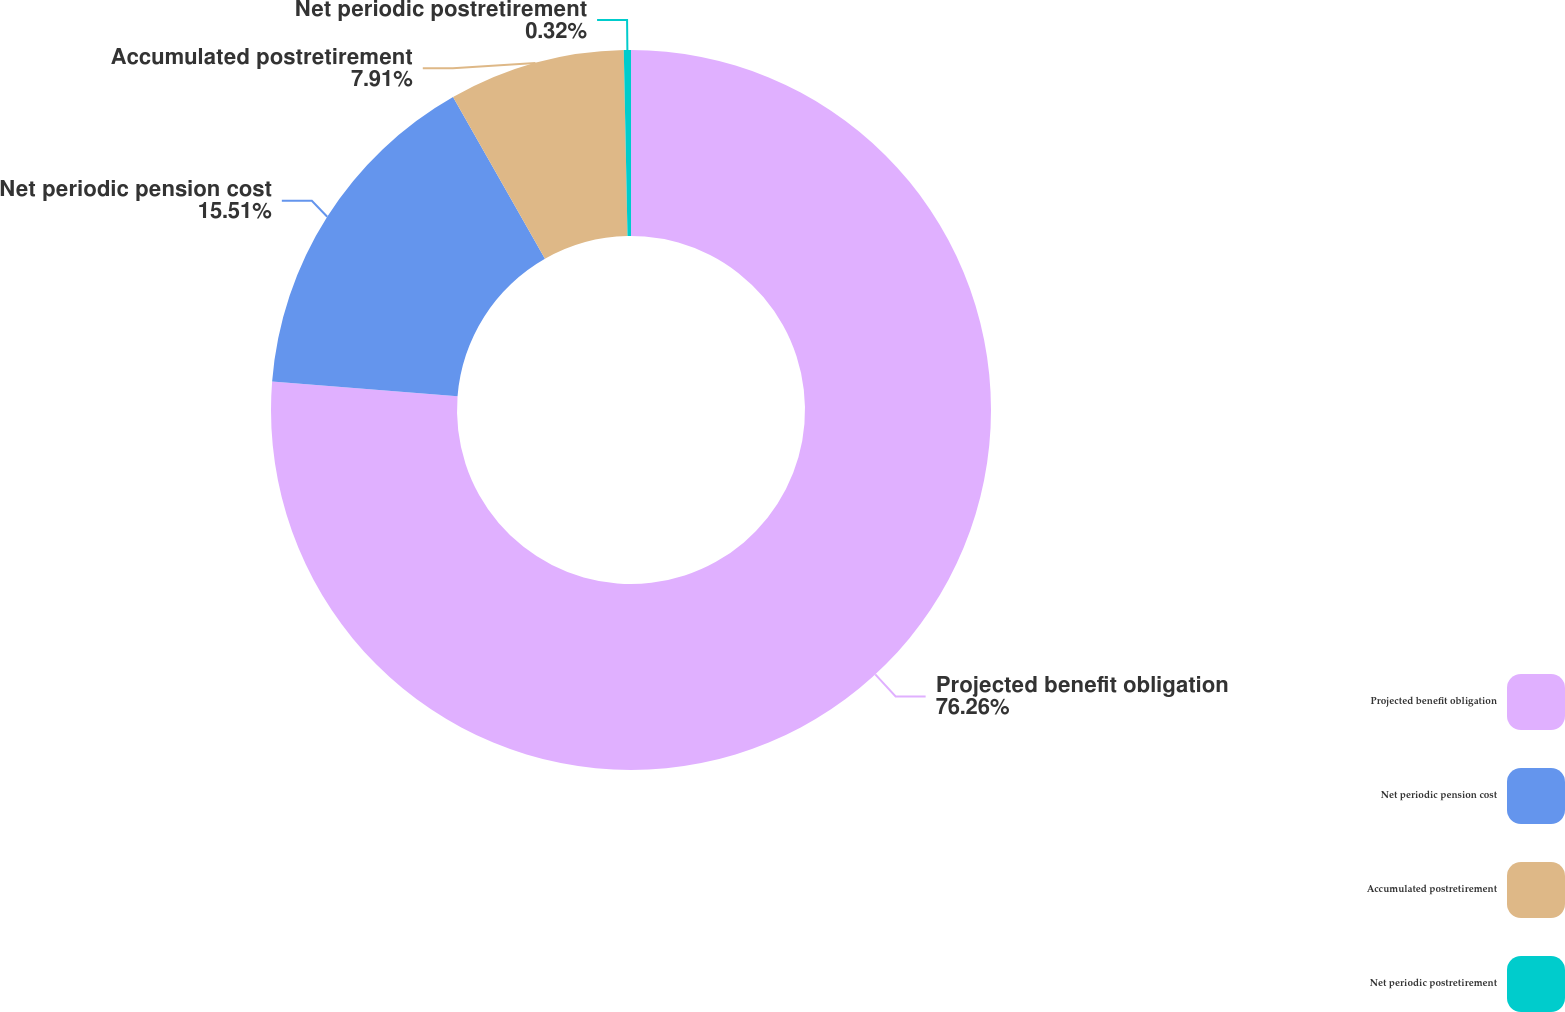<chart> <loc_0><loc_0><loc_500><loc_500><pie_chart><fcel>Projected benefit obligation<fcel>Net periodic pension cost<fcel>Accumulated postretirement<fcel>Net periodic postretirement<nl><fcel>76.26%<fcel>15.51%<fcel>7.91%<fcel>0.32%<nl></chart> 